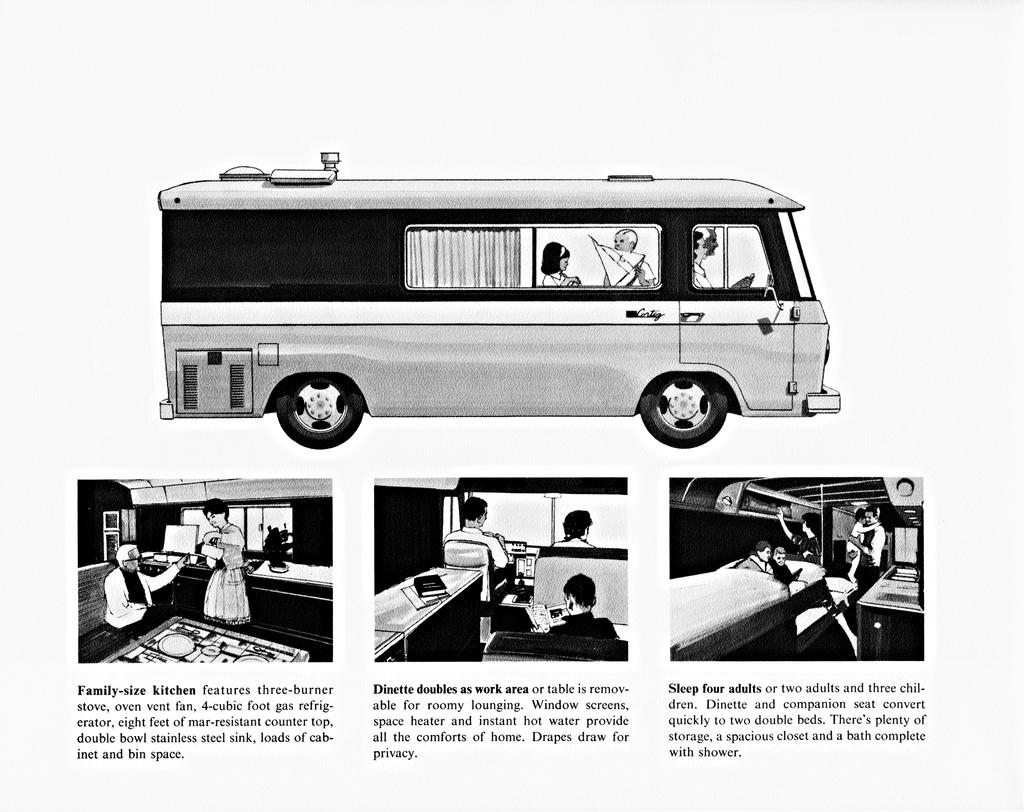<image>
Render a clear and concise summary of the photo. An ad for a recreational vehicle advertises a family size kitchen. 